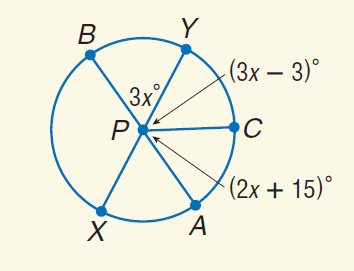Answer the mathemtical geometry problem and directly provide the correct option letter.
Question: Find m \widehat Y C.
Choices: A: 21 B: 60 C: 75 D: 180 B 